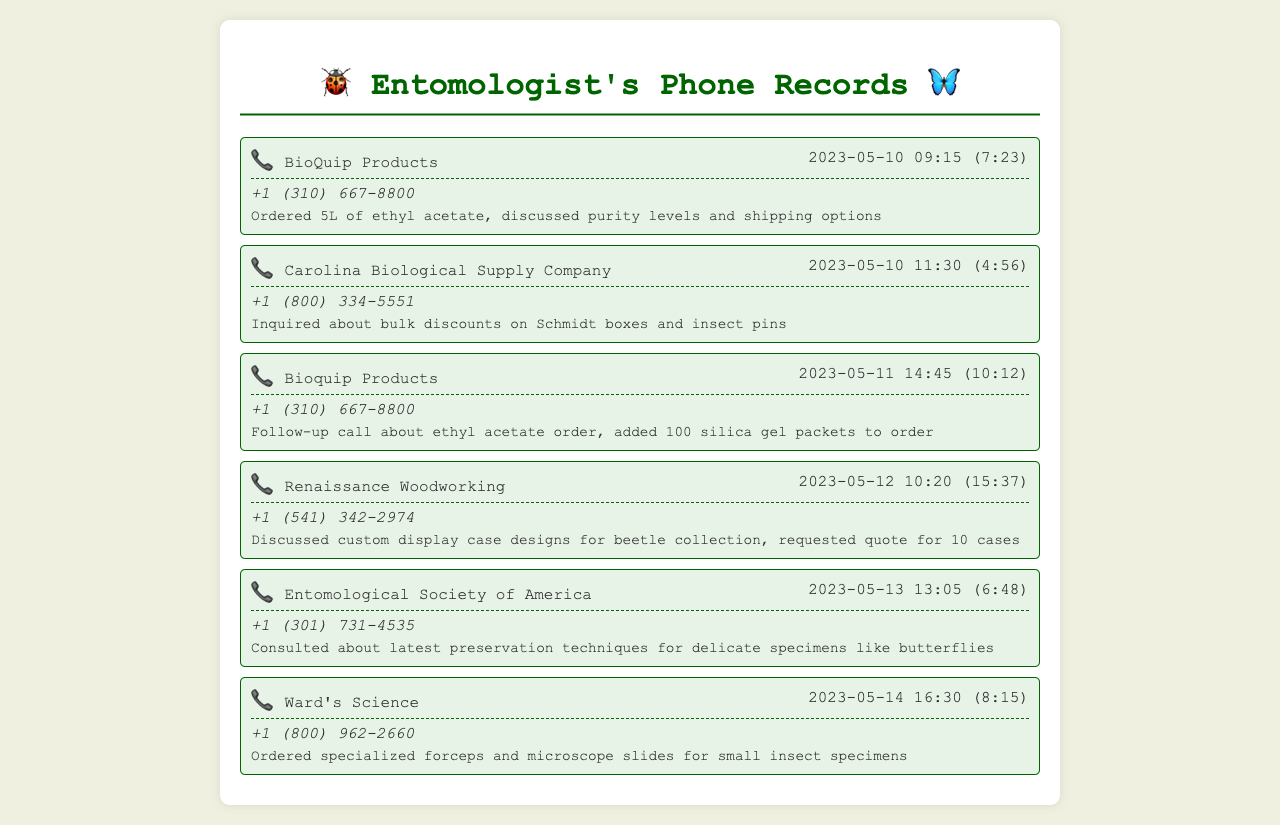What supplier was contacted for ordering ethyl acetate? The record shows that BioQuip Products was contacted for the ethyl acetate order.
Answer: BioQuip Products What was the date of the call to Carolina Biological Supply Company? The call to Carolina Biological Supply Company occurred on May 10, 2023.
Answer: 2023-05-10 How many silica gel packets were added to the order during the follow-up call? During the follow-up call, 100 silica gel packets were added to the order for ethyl acetate.
Answer: 100 What custom item was discussed with Renaissance Woodworking? The discussion with Renaissance Woodworking was about custom display case designs for a beetle collection.
Answer: custom display case designs Which company provided consultation on preservation techniques for delicate specimens? The Entomological Society of America provided the consultation on preservation techniques.
Answer: Entomological Society of America What type of materials were ordered from Ward's Science? The order from Ward's Science included specialized forceps and microscope slides for small insect specimens.
Answer: specialized forceps and microscope slides What was the duration of the call to BioQuip Products on May 10, 2023? The duration of the call to BioQuip Products on May 10, 2023, was 7 minutes and 23 seconds.
Answer: 7:23 Which company was contacted multiple times for ethyl acetate orders? BioQuip Products was contacted multiple times regarding ethyl acetate orders.
Answer: BioQuip Products 